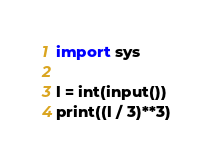Convert code to text. <code><loc_0><loc_0><loc_500><loc_500><_Python_>import sys

l = int(input())
print((l / 3)**3)
</code> 